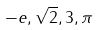Convert formula to latex. <formula><loc_0><loc_0><loc_500><loc_500>- e , \sqrt { 2 } , 3 , \pi</formula> 